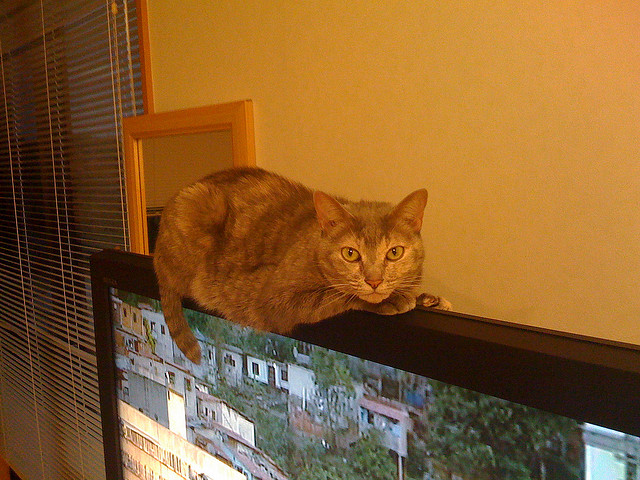<image>What do you think this cat's name is? I don't know what the cat's name is. It could be any name. What do you think this cat's name is? I don't know what this cat's name is. It could be any of the given options. 